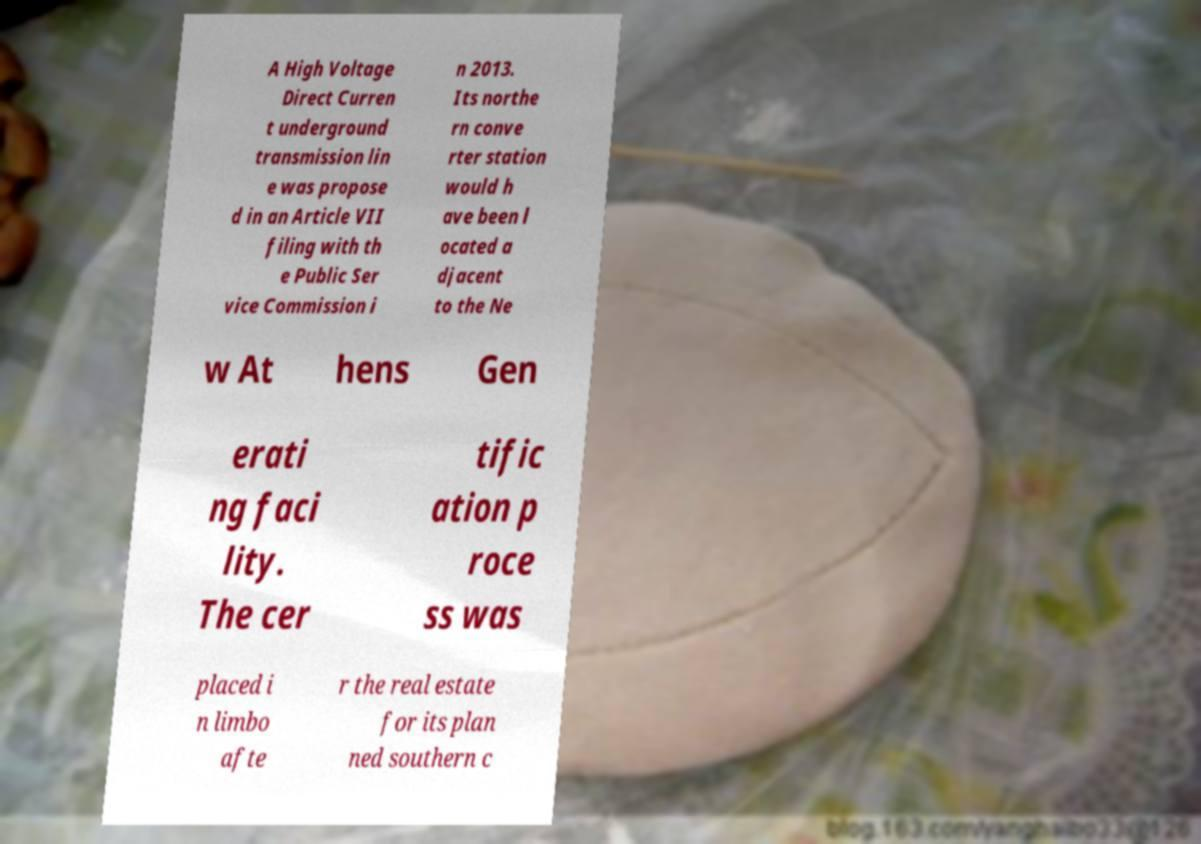Could you assist in decoding the text presented in this image and type it out clearly? A High Voltage Direct Curren t underground transmission lin e was propose d in an Article VII filing with th e Public Ser vice Commission i n 2013. Its northe rn conve rter station would h ave been l ocated a djacent to the Ne w At hens Gen erati ng faci lity. The cer tific ation p roce ss was placed i n limbo afte r the real estate for its plan ned southern c 